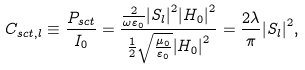Convert formula to latex. <formula><loc_0><loc_0><loc_500><loc_500>C _ { s c t , l } \equiv \frac { { { P _ { s c t } } } } { I _ { 0 } } = \frac { { \frac { 2 } { { \omega { \varepsilon _ { 0 } } } } { { \left | { S _ { l } } \right | } ^ { 2 } } { { \left | { H _ { 0 } } \right | } ^ { 2 } } } } { { \frac { 1 } { 2 } \sqrt { \frac { \mu _ { 0 } } { \varepsilon _ { 0 } } } { { \left | { H _ { 0 } } \right | } ^ { 2 } } } } = \frac { 2 \lambda } { \pi } { \left | { S _ { l } } \right | ^ { 2 } } ,</formula> 